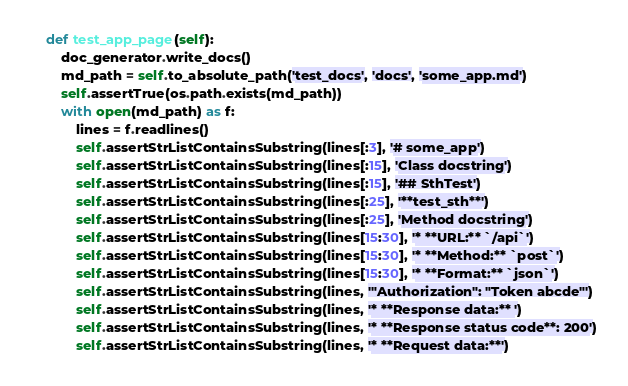<code> <loc_0><loc_0><loc_500><loc_500><_Python_>
    def test_app_page(self):
        doc_generator.write_docs()
        md_path = self.to_absolute_path('test_docs', 'docs', 'some_app.md')
        self.assertTrue(os.path.exists(md_path))
        with open(md_path) as f:
            lines = f.readlines()
            self.assertStrListContainsSubstring(lines[:3], '# some_app')
            self.assertStrListContainsSubstring(lines[:15], 'Class docstring')
            self.assertStrListContainsSubstring(lines[:15], '## SthTest')
            self.assertStrListContainsSubstring(lines[:25], '**test_sth**')
            self.assertStrListContainsSubstring(lines[:25], 'Method docstring')
            self.assertStrListContainsSubstring(lines[15:30], '* **URL:** `/api`')
            self.assertStrListContainsSubstring(lines[15:30], '* **Method:** `post`')
            self.assertStrListContainsSubstring(lines[15:30], '* **Format:** `json`')
            self.assertStrListContainsSubstring(lines, '"Authorization": "Token abcde"')
            self.assertStrListContainsSubstring(lines, '* **Response data:** ')
            self.assertStrListContainsSubstring(lines, '* **Response status code**: 200')
            self.assertStrListContainsSubstring(lines, '* **Request data:**')
</code> 